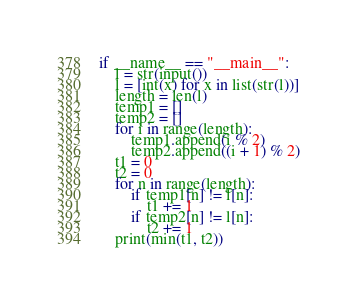Convert code to text. <code><loc_0><loc_0><loc_500><loc_500><_Python_>if __name__ == "__main__":
    l = str(input())
    l = [int(x) for x in list(str(l))]
    length = len(l)
    temp1 = []
    temp2 = []
    for i in range(length):
        temp1.append(i % 2)
        temp2.append((i + 1) % 2)
    t1 = 0
    t2 = 0
    for n in range(length):
        if temp1[n] != l[n]:
            t1 += 1
        if temp2[n] != l[n]:
            t2 += 1
    print(min(t1, t2))
</code> 